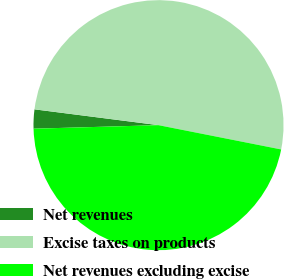Convert chart to OTSL. <chart><loc_0><loc_0><loc_500><loc_500><pie_chart><fcel>Net revenues<fcel>Excise taxes on products<fcel>Net revenues excluding excise<nl><fcel>2.47%<fcel>51.09%<fcel>46.44%<nl></chart> 